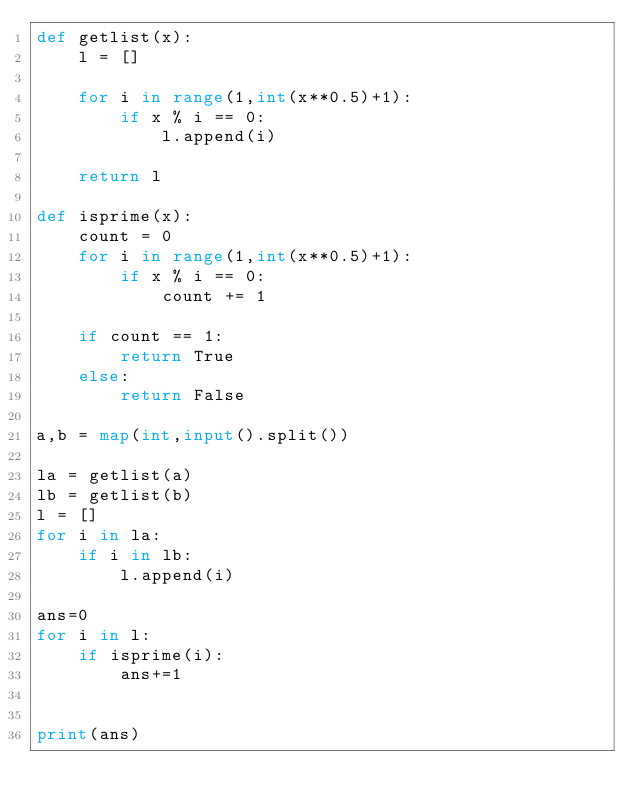<code> <loc_0><loc_0><loc_500><loc_500><_Python_>def getlist(x):
    l = []
    
    for i in range(1,int(x**0.5)+1):
        if x % i == 0:
            l.append(i)
      
    return l
  
def isprime(x):
    count = 0
    for i in range(1,int(x**0.5)+1):
        if x % i == 0:
            count += 1
      
    if count == 1:
        return True
    else:
        return False

a,b = map(int,input().split())

la = getlist(a)
lb = getlist(b)
l = []
for i in la:
    if i in lb:
        l.append(i)

ans=0
for i in l:
    if isprime(i):
        ans+=1
       

print(ans)
  

  

  

  

  
</code> 